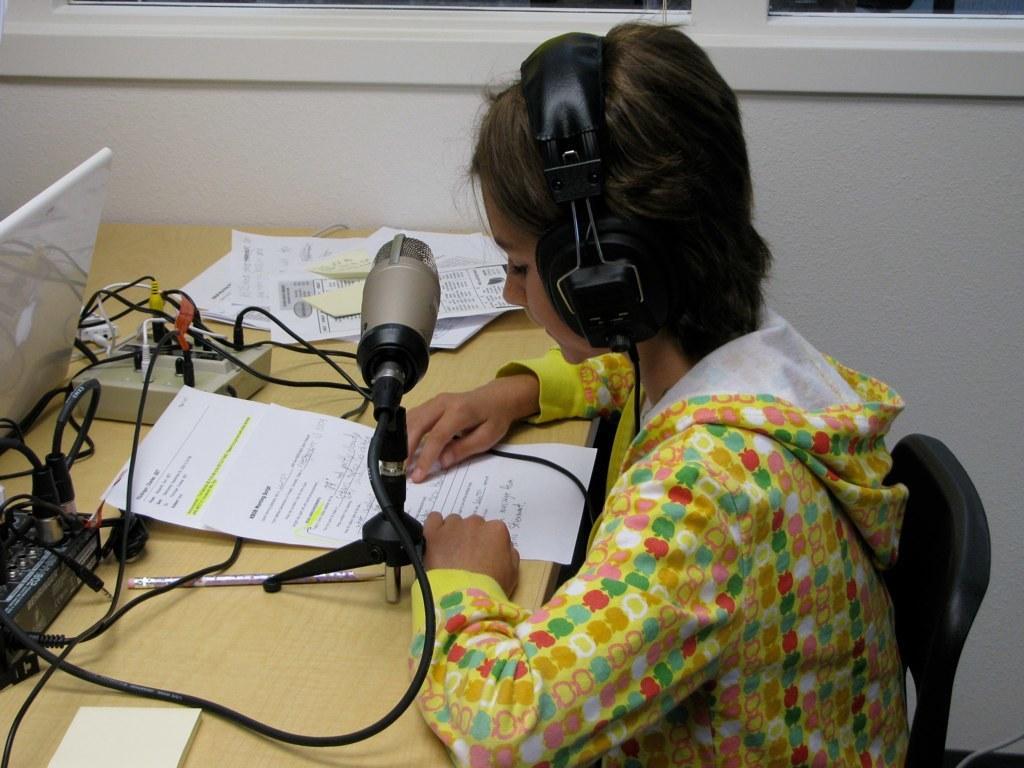Could you give a brief overview of what you see in this image? In this image I can see there is a girl sitting on the chair, she is wearing headphones and there is a table in front of her, there are a few papers and a laptop placed on the table. 